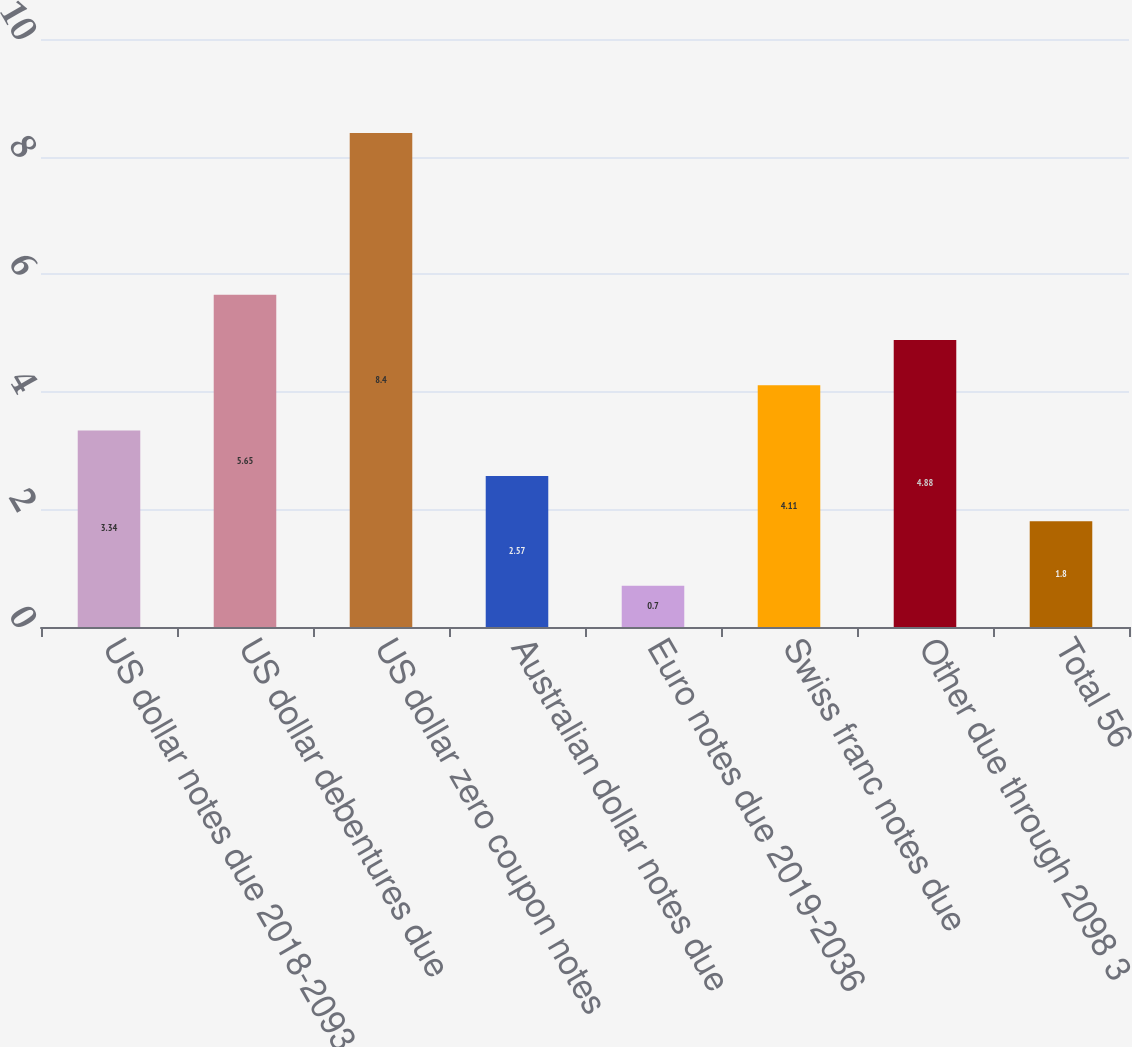Convert chart. <chart><loc_0><loc_0><loc_500><loc_500><bar_chart><fcel>US dollar notes due 2018-2093<fcel>US dollar debentures due<fcel>US dollar zero coupon notes<fcel>Australian dollar notes due<fcel>Euro notes due 2019-2036<fcel>Swiss franc notes due<fcel>Other due through 2098 3<fcel>Total 56<nl><fcel>3.34<fcel>5.65<fcel>8.4<fcel>2.57<fcel>0.7<fcel>4.11<fcel>4.88<fcel>1.8<nl></chart> 